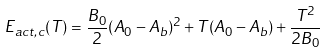Convert formula to latex. <formula><loc_0><loc_0><loc_500><loc_500>E _ { a c t , c } ( T ) = \frac { B _ { 0 } } { 2 } ( A _ { 0 } - A _ { b } ) ^ { 2 } + T ( A _ { 0 } - A _ { b } ) + \frac { T ^ { 2 } } { 2 B _ { 0 } }</formula> 